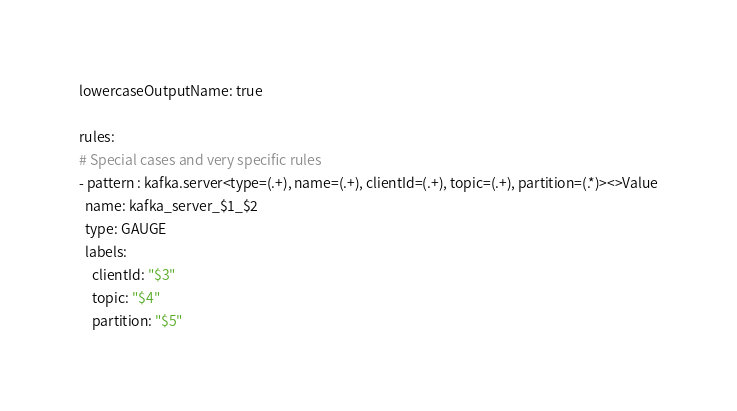<code> <loc_0><loc_0><loc_500><loc_500><_YAML_>lowercaseOutputName: true

rules:
# Special cases and very specific rules
- pattern : kafka.server<type=(.+), name=(.+), clientId=(.+), topic=(.+), partition=(.*)><>Value
  name: kafka_server_$1_$2
  type: GAUGE
  labels:
    clientId: "$3"
    topic: "$4"
    partition: "$5"</code> 